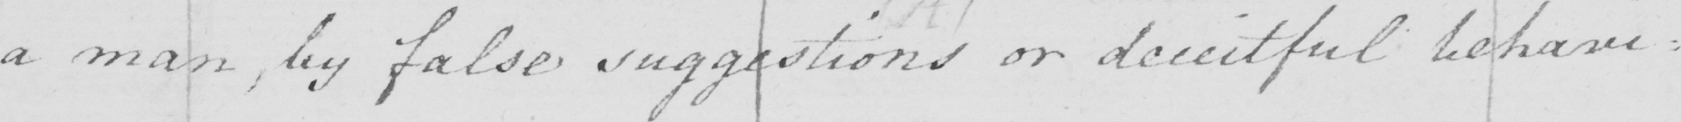Transcribe the text shown in this historical manuscript line. a man , by false suggestions or deceitful behavi : 